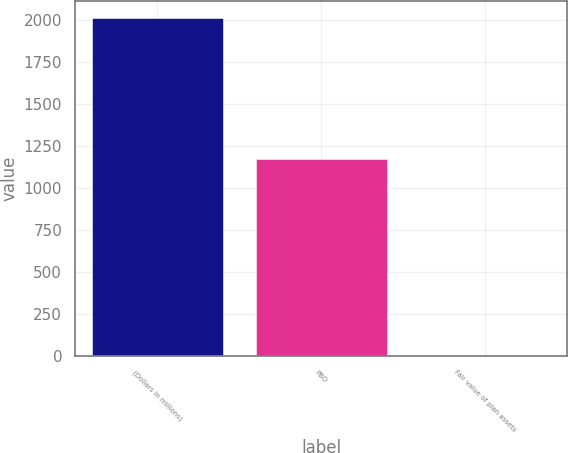Convert chart. <chart><loc_0><loc_0><loc_500><loc_500><bar_chart><fcel>(Dollars in millions)<fcel>PBO<fcel>Fair value of plan assets<nl><fcel>2011<fcel>1174<fcel>2<nl></chart> 